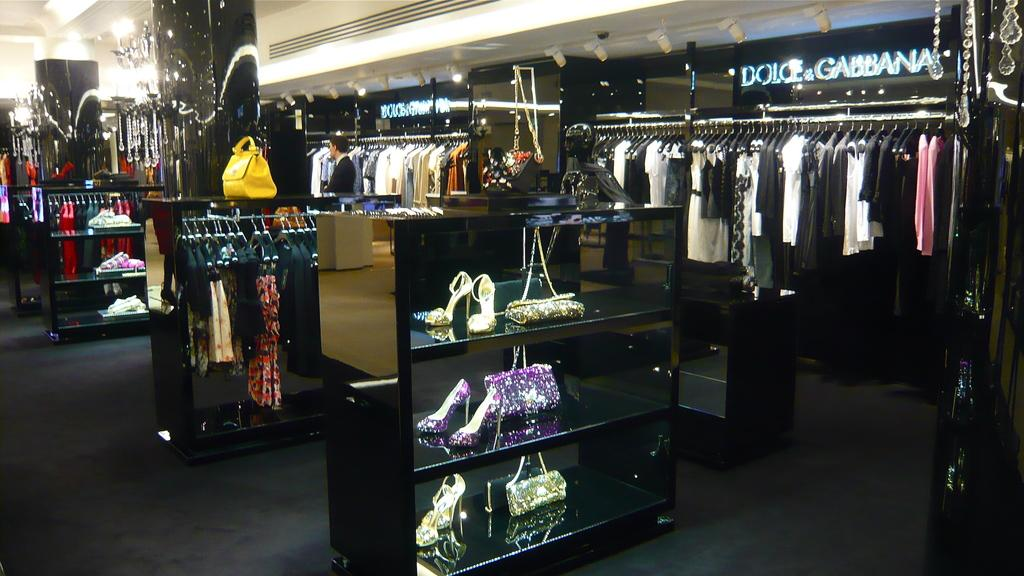Provide a one-sentence caption for the provided image. Dolce and Gabbana boutique store inside a mall. 